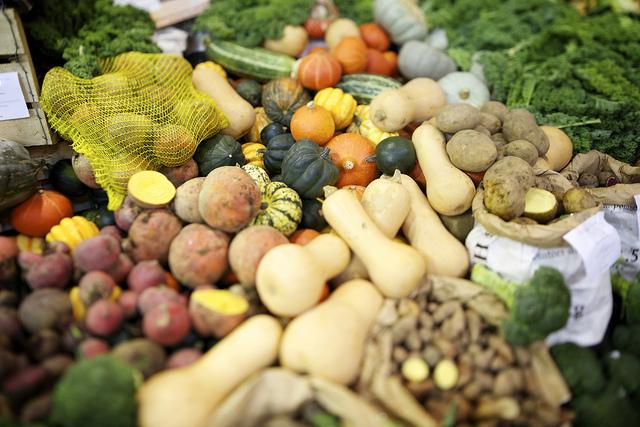What vegetables are shown?
Concise answer only. Squash. Is this most likely at a farmers market or a grocery store?
Be succinct. Farmers market. What type of fruit is shown?
Answer briefly. Squash. What is for seal?
Concise answer only. Vegetables. What are 2 types of vegetables shown?
Short answer required. Squash and potatoes. What are two of the vegetables present?
Be succinct. Potato and squash. What color is this plant?
Keep it brief. Green. Are there more fruits or vegetables?
Answer briefly. Vegetables. What kind of fruit is shown?
Be succinct. Squash. What is the green veggie?
Concise answer only. Broccoli. Is this fruit bananas?
Give a very brief answer. No. How many different veggies are there?
Short answer required. Lots. What are the orange vegetables?
Quick response, please. Squash. What color is this vegetable?
Quick response, please. Orange. 